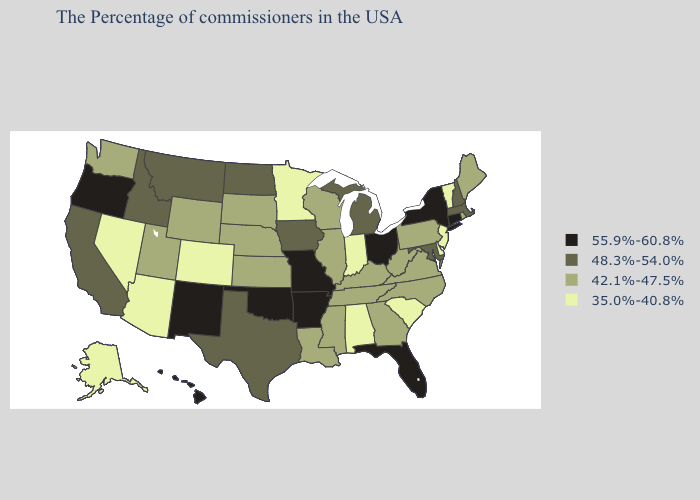Among the states that border Utah , which have the lowest value?
Short answer required. Colorado, Arizona, Nevada. What is the lowest value in the Northeast?
Write a very short answer. 35.0%-40.8%. Which states have the highest value in the USA?
Concise answer only. Connecticut, New York, Ohio, Florida, Missouri, Arkansas, Oklahoma, New Mexico, Oregon, Hawaii. Does South Carolina have the lowest value in the USA?
Answer briefly. Yes. What is the value of Nevada?
Quick response, please. 35.0%-40.8%. Which states have the lowest value in the USA?
Write a very short answer. Vermont, New Jersey, Delaware, South Carolina, Indiana, Alabama, Minnesota, Colorado, Arizona, Nevada, Alaska. Name the states that have a value in the range 55.9%-60.8%?
Answer briefly. Connecticut, New York, Ohio, Florida, Missouri, Arkansas, Oklahoma, New Mexico, Oregon, Hawaii. How many symbols are there in the legend?
Short answer required. 4. What is the value of Kansas?
Be succinct. 42.1%-47.5%. Name the states that have a value in the range 55.9%-60.8%?
Quick response, please. Connecticut, New York, Ohio, Florida, Missouri, Arkansas, Oklahoma, New Mexico, Oregon, Hawaii. Which states have the lowest value in the Northeast?
Answer briefly. Vermont, New Jersey. Among the states that border Nebraska , does Colorado have the lowest value?
Concise answer only. Yes. Does Nebraska have a higher value than West Virginia?
Be succinct. No. Does Oklahoma have the highest value in the South?
Write a very short answer. Yes. How many symbols are there in the legend?
Answer briefly. 4. 